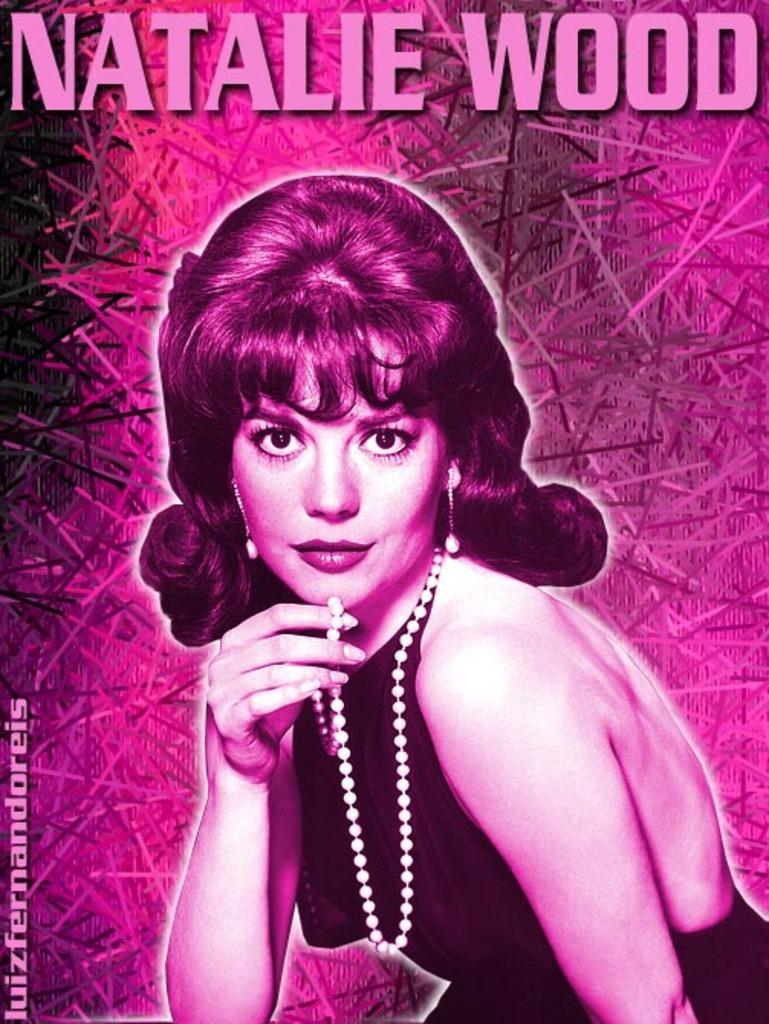What is the main object in the picture? There is a magazine in the picture. What can be seen on the cover of the magazine? The magazine has an image of a woman on it. What is the woman in the image wearing? The woman in the image is wearing a pearl necklace. What name is visible on the magazine? The name "Natalie Wood" is visible on the magazine. What type of underwear is the woman wearing in the image? There is no information about the woman's underwear in the image, as the focus is on the image of her and the pearl necklace. 